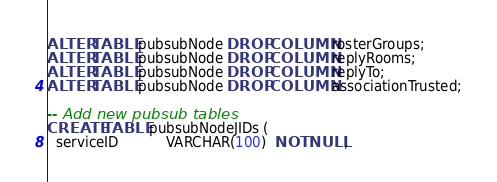Convert code to text. <code><loc_0><loc_0><loc_500><loc_500><_SQL_>ALTER TABLE pubsubNode DROP COLUMN rosterGroups;
ALTER TABLE pubsubNode DROP COLUMN replyRooms;
ALTER TABLE pubsubNode DROP COLUMN replyTo;
ALTER TABLE pubsubNode DROP COLUMN associationTrusted;

-- Add new pubsub tables
CREATE TABLE pubsubNodeJIDs (
  serviceID           VARCHAR(100)  NOT NULL,</code> 